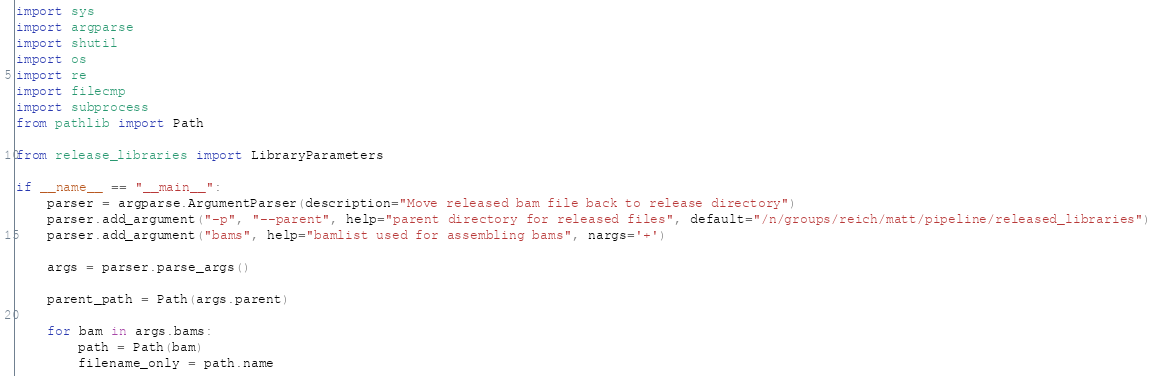Convert code to text. <code><loc_0><loc_0><loc_500><loc_500><_Python_>import sys
import argparse
import shutil
import os
import re
import filecmp
import subprocess
from pathlib import Path

from release_libraries import LibraryParameters

if __name__ == "__main__":
	parser = argparse.ArgumentParser(description="Move released bam file back to release directory")
	parser.add_argument("-p", "--parent", help="parent directory for released files", default="/n/groups/reich/matt/pipeline/released_libraries")
	parser.add_argument("bams", help="bamlist used for assembling bams", nargs='+')
	
	args = parser.parse_args()
	
	parent_path = Path(args.parent)
	
	for bam in args.bams:
		path = Path(bam)
		filename_only = path.name</code> 